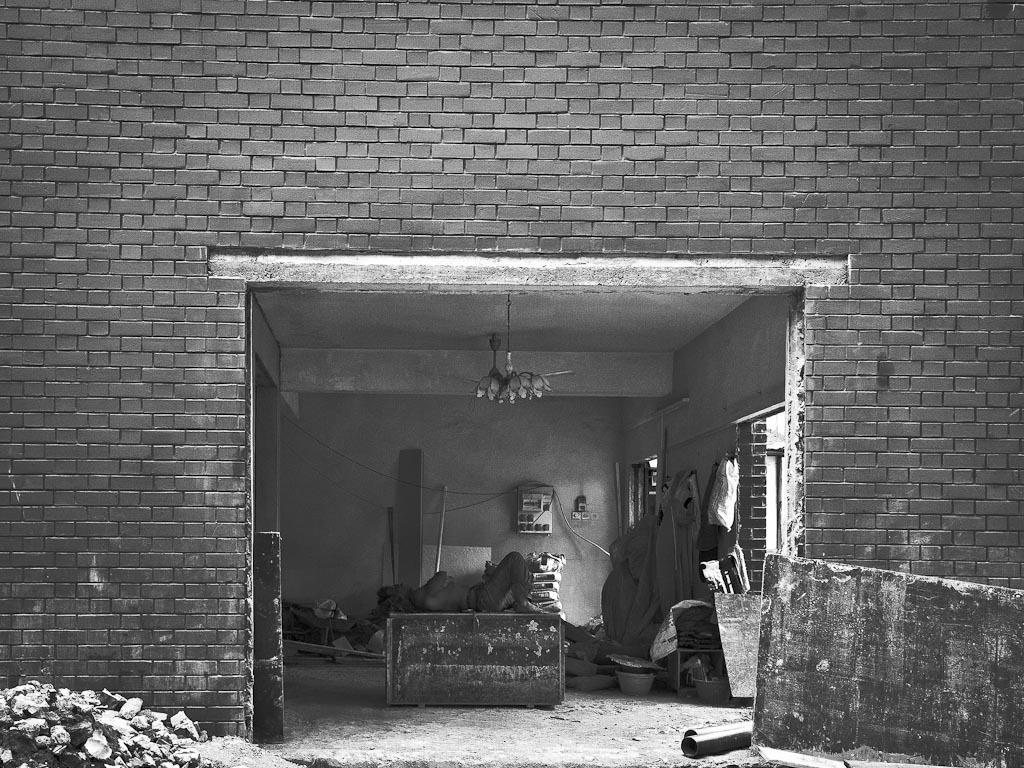In one or two sentences, can you explain what this image depicts? I see this image is of white and black in color and I see the wall and I see a person over here who is lying and I see many things and I see the ground. 